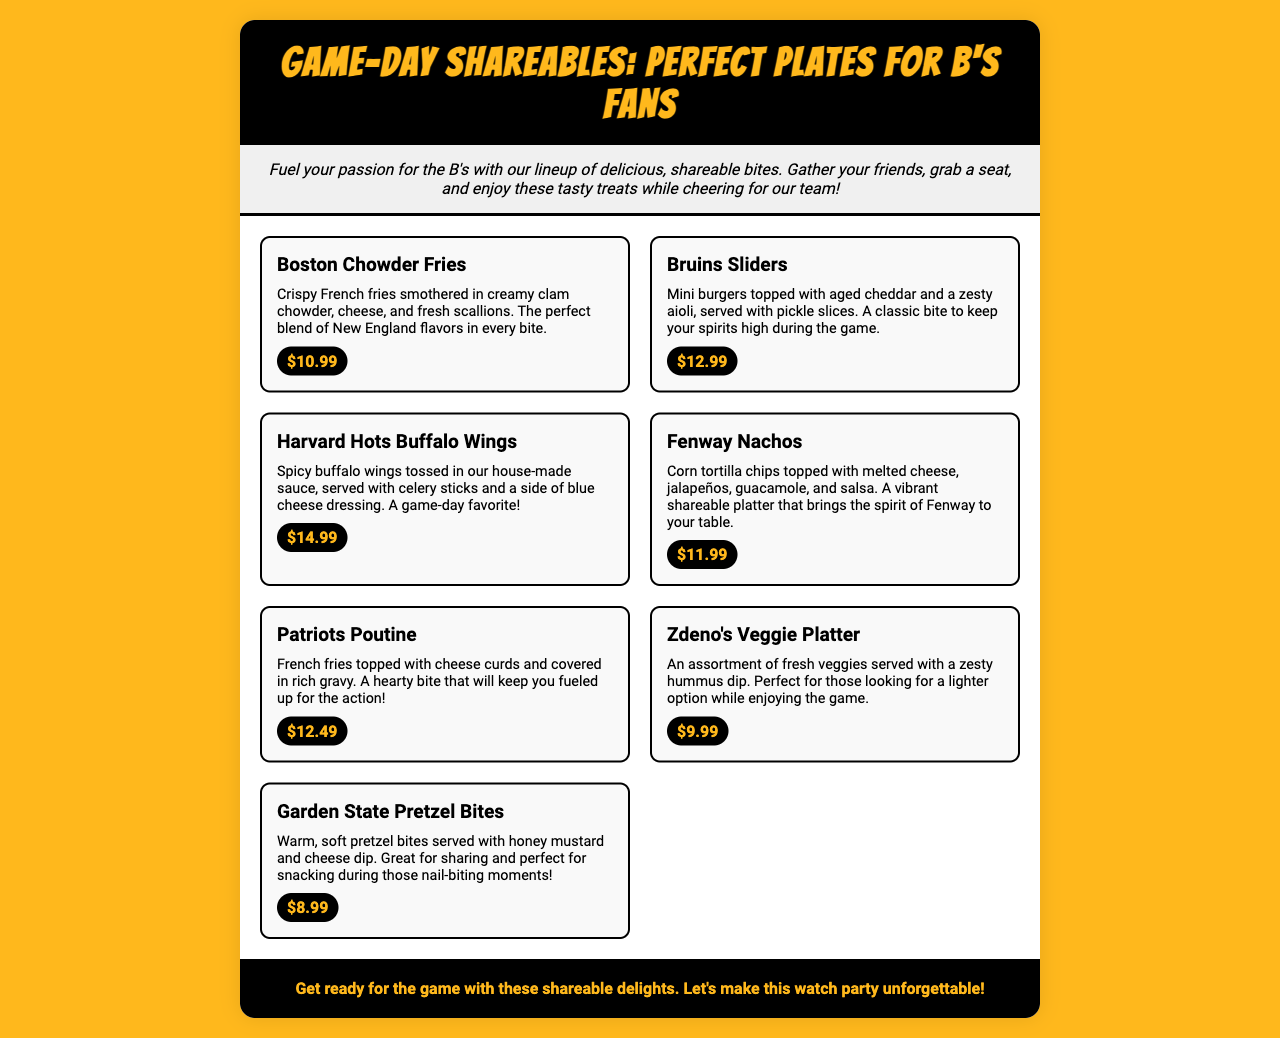What is the name of the first menu item? The first menu item listed is "Boston Chowder Fries."
Answer: Boston Chowder Fries What is the price of Bruins Sliders? The price of the Bruins Sliders is specifically mentioned in the menu as $12.99.
Answer: $12.99 How many items are there in the shareables menu? The document lists a total of seven different items in the menu section.
Answer: Seven Which menu item is described as "great for sharing"? "Garden State Pretzel Bites" is noted to be great for sharing during the game.
Answer: Garden State Pretzel Bites What topping is mentioned with the Harvard Hots Buffalo Wings? The menu describes blue cheese dressing as one of the accompaniments to the wings.
Answer: Blue cheese dressing What is the description for Fenway Nachos? The specific description provided mentions they are topped with melted cheese, jalapeños, guacamole, and salsa.
Answer: Corn tortilla chips topped with melted cheese, jalapeños, guacamole, and salsa What type of platter is the Zdeno's Veggie Platter? The Zdeno's Veggie Platter is an assortment of fresh veggies served with hummus.
Answer: Assortment of fresh veggies What color is the background of the menu? The overall background color of the menu is specified as yellow (#FFB81C).
Answer: Yellow 